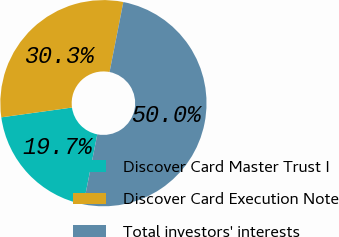Convert chart to OTSL. <chart><loc_0><loc_0><loc_500><loc_500><pie_chart><fcel>Discover Card Master Trust I<fcel>Discover Card Execution Note<fcel>Total investors' interests<nl><fcel>19.71%<fcel>30.29%<fcel>50.0%<nl></chart> 